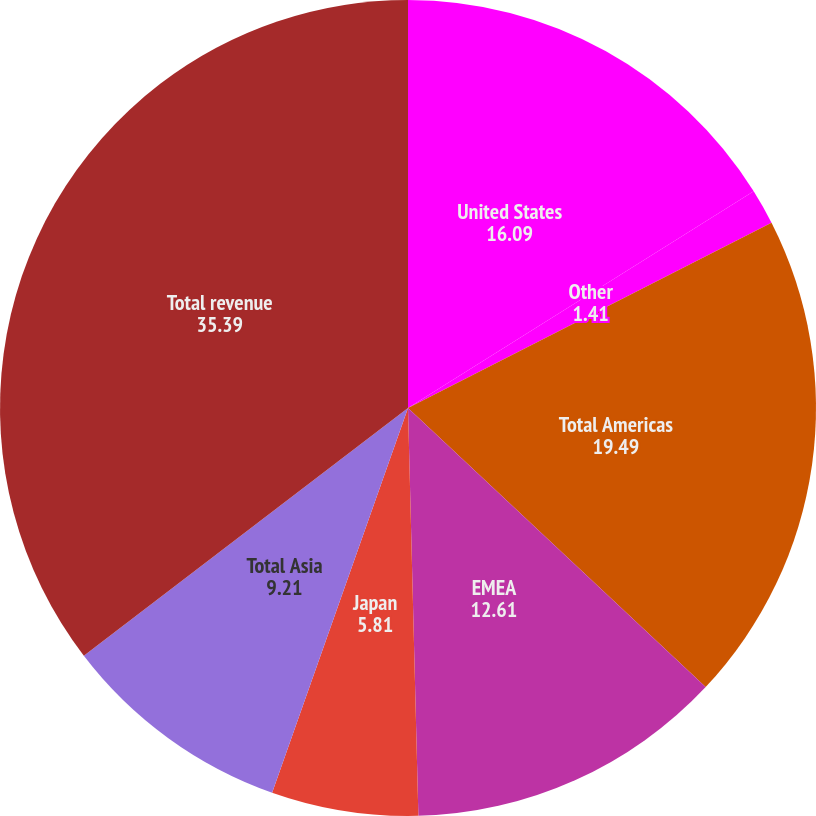<chart> <loc_0><loc_0><loc_500><loc_500><pie_chart><fcel>United States<fcel>Other<fcel>Total Americas<fcel>EMEA<fcel>Japan<fcel>Total Asia<fcel>Total revenue<nl><fcel>16.09%<fcel>1.41%<fcel>19.49%<fcel>12.61%<fcel>5.81%<fcel>9.21%<fcel>35.39%<nl></chart> 